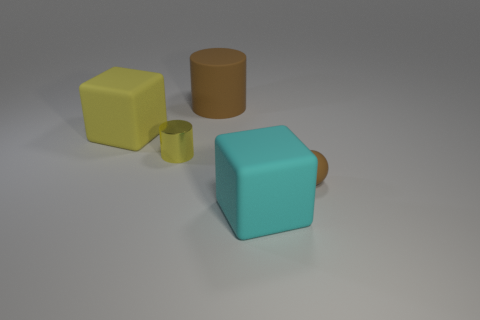Add 4 yellow cylinders. How many objects exist? 9 Subtract all cubes. How many objects are left? 3 Add 2 small cylinders. How many small cylinders exist? 3 Subtract all cyan blocks. How many blocks are left? 1 Subtract 0 blue spheres. How many objects are left? 5 Subtract 1 cylinders. How many cylinders are left? 1 Subtract all yellow balls. Subtract all purple blocks. How many balls are left? 1 Subtract all large metallic objects. Subtract all large brown objects. How many objects are left? 4 Add 2 small yellow things. How many small yellow things are left? 3 